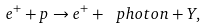<formula> <loc_0><loc_0><loc_500><loc_500>e ^ { + } + p \rightarrow e ^ { + } + \ p h o t o n + Y ,</formula> 